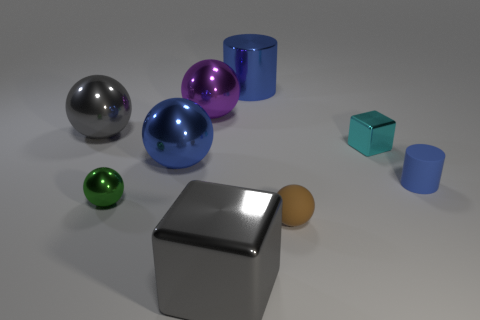Subtract all large purple spheres. How many spheres are left? 4 Add 1 small yellow matte balls. How many objects exist? 10 Subtract all purple balls. How many balls are left? 4 Subtract all blocks. How many objects are left? 7 Subtract all purple spheres. Subtract all gray cubes. How many spheres are left? 4 Subtract all tiny rubber spheres. Subtract all green things. How many objects are left? 7 Add 4 blue objects. How many blue objects are left? 7 Add 4 blue balls. How many blue balls exist? 5 Subtract 0 cyan cylinders. How many objects are left? 9 